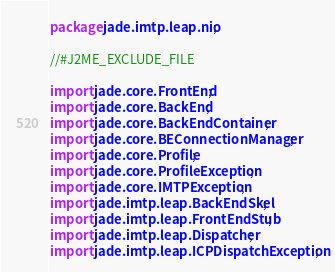Convert code to text. <code><loc_0><loc_0><loc_500><loc_500><_Java_>package jade.imtp.leap.nio;

//#J2ME_EXCLUDE_FILE

import jade.core.FrontEnd;
import jade.core.BackEnd;
import jade.core.BackEndContainer;
import jade.core.BEConnectionManager;
import jade.core.Profile;
import jade.core.ProfileException;
import jade.core.IMTPException;
import jade.imtp.leap.BackEndSkel;
import jade.imtp.leap.FrontEndStub;
import jade.imtp.leap.Dispatcher;
import jade.imtp.leap.ICPDispatchException;</code> 